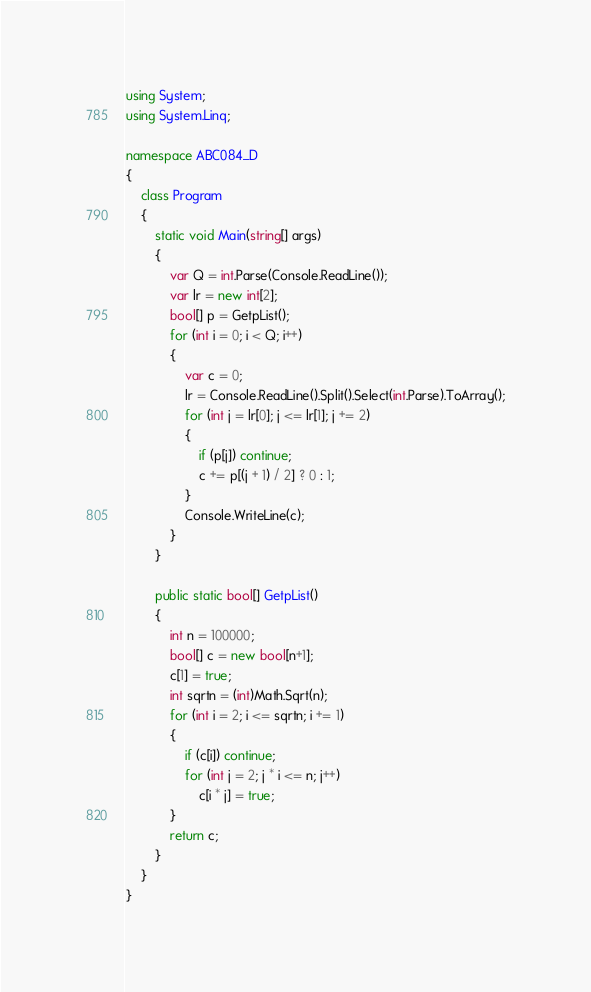<code> <loc_0><loc_0><loc_500><loc_500><_C#_>using System;
using System.Linq;

namespace ABC084_D
{
    class Program
    {
        static void Main(string[] args)
        {
            var Q = int.Parse(Console.ReadLine());
            var lr = new int[2];
            bool[] p = GetpList();
            for (int i = 0; i < Q; i++)
            {
                var c = 0;
                lr = Console.ReadLine().Split().Select(int.Parse).ToArray();
                for (int j = lr[0]; j <= lr[1]; j += 2)
                {
                    if (p[j]) continue;
                    c += p[(j + 1) / 2] ? 0 : 1;
                }
                Console.WriteLine(c);
            }
        }

        public static bool[] GetpList()
        {
            int n = 100000;
            bool[] c = new bool[n+1];
            c[1] = true;
            int sqrtn = (int)Math.Sqrt(n);
            for (int i = 2; i <= sqrtn; i += 1)
            {
                if (c[i]) continue;
                for (int j = 2; j * i <= n; j++)
                    c[i * j] = true;
            }
            return c;
        }
    }
}
</code> 